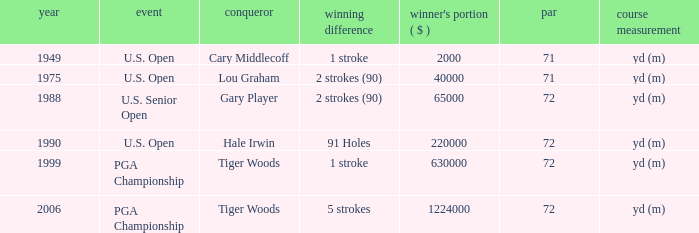When hale irwin is the winner what is the margin of victory? 91 Holes. 